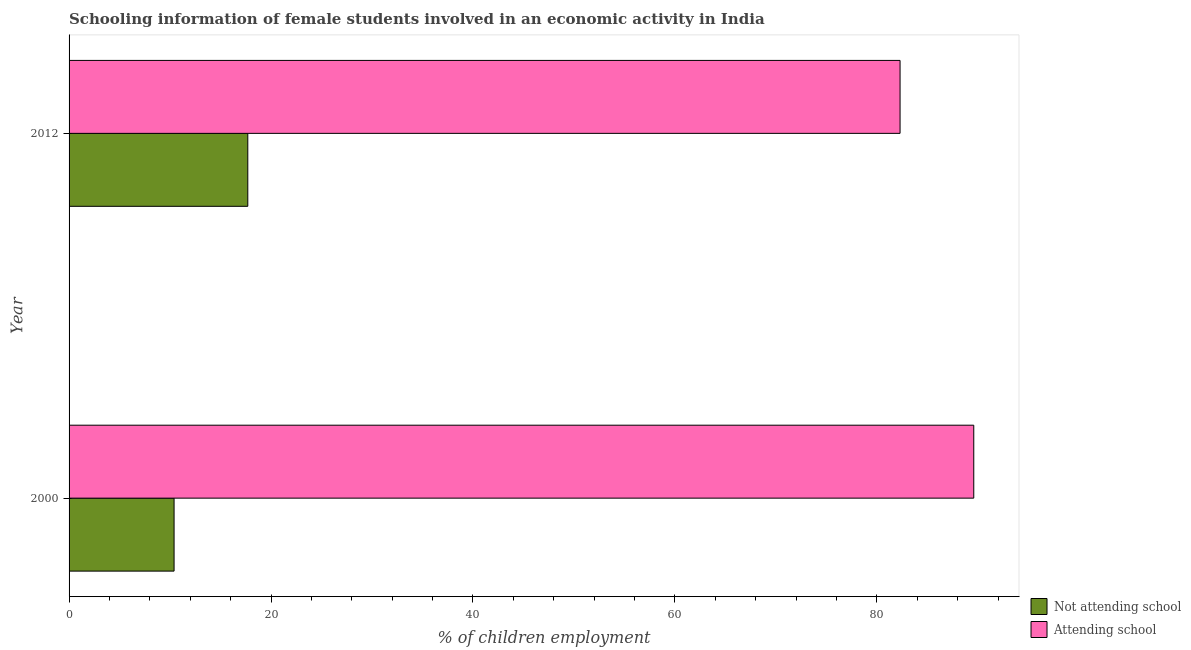How many different coloured bars are there?
Make the answer very short. 2. How many groups of bars are there?
Give a very brief answer. 2. How many bars are there on the 2nd tick from the top?
Make the answer very short. 2. How many bars are there on the 1st tick from the bottom?
Ensure brevity in your answer.  2. Across all years, what is the maximum percentage of employed females who are attending school?
Your answer should be very brief. 89.6. What is the total percentage of employed females who are attending school in the graph?
Provide a succinct answer. 171.9. What is the difference between the percentage of employed females who are attending school in 2000 and that in 2012?
Ensure brevity in your answer.  7.3. What is the difference between the percentage of employed females who are not attending school in 2000 and the percentage of employed females who are attending school in 2012?
Give a very brief answer. -71.9. What is the average percentage of employed females who are not attending school per year?
Provide a succinct answer. 14.05. In the year 2000, what is the difference between the percentage of employed females who are attending school and percentage of employed females who are not attending school?
Provide a succinct answer. 79.2. In how many years, is the percentage of employed females who are attending school greater than 40 %?
Provide a short and direct response. 2. What is the ratio of the percentage of employed females who are attending school in 2000 to that in 2012?
Offer a very short reply. 1.09. In how many years, is the percentage of employed females who are attending school greater than the average percentage of employed females who are attending school taken over all years?
Your response must be concise. 1. What does the 2nd bar from the top in 2000 represents?
Provide a short and direct response. Not attending school. What does the 2nd bar from the bottom in 2000 represents?
Offer a terse response. Attending school. How many bars are there?
Ensure brevity in your answer.  4. How many years are there in the graph?
Provide a short and direct response. 2. What is the difference between two consecutive major ticks on the X-axis?
Offer a terse response. 20. Are the values on the major ticks of X-axis written in scientific E-notation?
Provide a short and direct response. No. Does the graph contain any zero values?
Provide a succinct answer. No. Does the graph contain grids?
Provide a short and direct response. No. Where does the legend appear in the graph?
Give a very brief answer. Bottom right. How many legend labels are there?
Make the answer very short. 2. What is the title of the graph?
Provide a succinct answer. Schooling information of female students involved in an economic activity in India. What is the label or title of the X-axis?
Your answer should be compact. % of children employment. What is the % of children employment of Not attending school in 2000?
Offer a very short reply. 10.4. What is the % of children employment of Attending school in 2000?
Make the answer very short. 89.6. What is the % of children employment in Not attending school in 2012?
Your response must be concise. 17.7. What is the % of children employment of Attending school in 2012?
Provide a succinct answer. 82.3. Across all years, what is the maximum % of children employment in Attending school?
Your answer should be compact. 89.6. Across all years, what is the minimum % of children employment in Attending school?
Your response must be concise. 82.3. What is the total % of children employment in Not attending school in the graph?
Your answer should be very brief. 28.1. What is the total % of children employment in Attending school in the graph?
Provide a succinct answer. 171.9. What is the difference between the % of children employment in Not attending school in 2000 and that in 2012?
Offer a terse response. -7.3. What is the difference between the % of children employment of Not attending school in 2000 and the % of children employment of Attending school in 2012?
Your answer should be compact. -71.9. What is the average % of children employment of Not attending school per year?
Keep it short and to the point. 14.05. What is the average % of children employment of Attending school per year?
Ensure brevity in your answer.  85.95. In the year 2000, what is the difference between the % of children employment of Not attending school and % of children employment of Attending school?
Offer a very short reply. -79.2. In the year 2012, what is the difference between the % of children employment in Not attending school and % of children employment in Attending school?
Offer a terse response. -64.6. What is the ratio of the % of children employment of Not attending school in 2000 to that in 2012?
Provide a succinct answer. 0.59. What is the ratio of the % of children employment of Attending school in 2000 to that in 2012?
Your answer should be very brief. 1.09. What is the difference between the highest and the second highest % of children employment of Not attending school?
Ensure brevity in your answer.  7.3. What is the difference between the highest and the lowest % of children employment in Not attending school?
Offer a terse response. 7.3. 